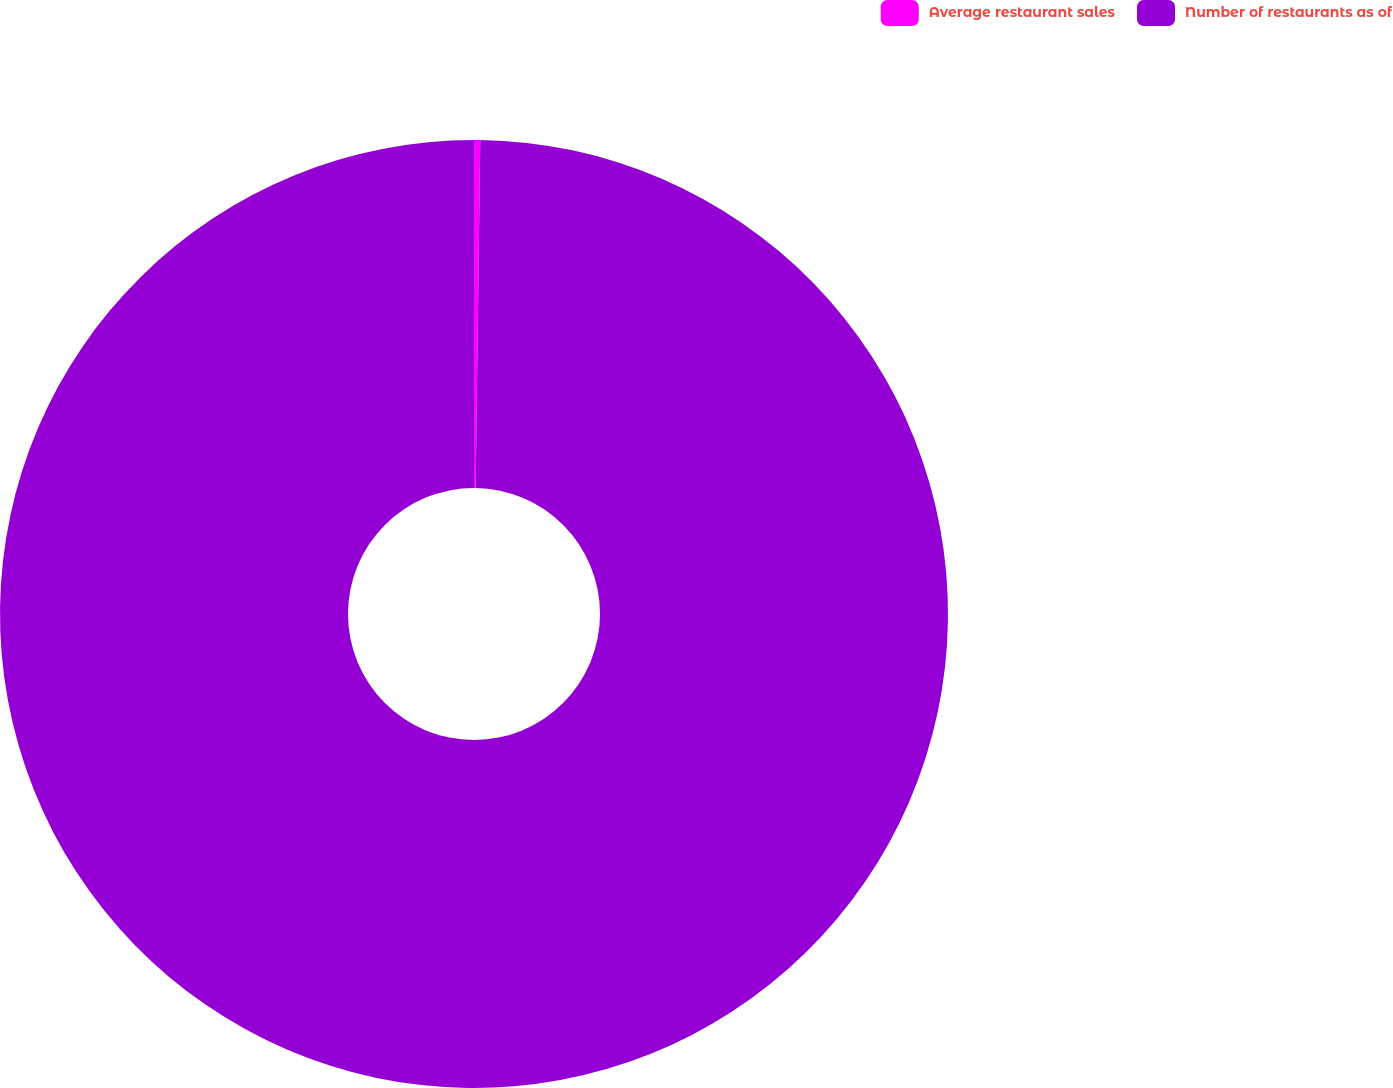Convert chart. <chart><loc_0><loc_0><loc_500><loc_500><pie_chart><fcel>Average restaurant sales<fcel>Number of restaurants as of<nl><fcel>0.21%<fcel>99.79%<nl></chart> 